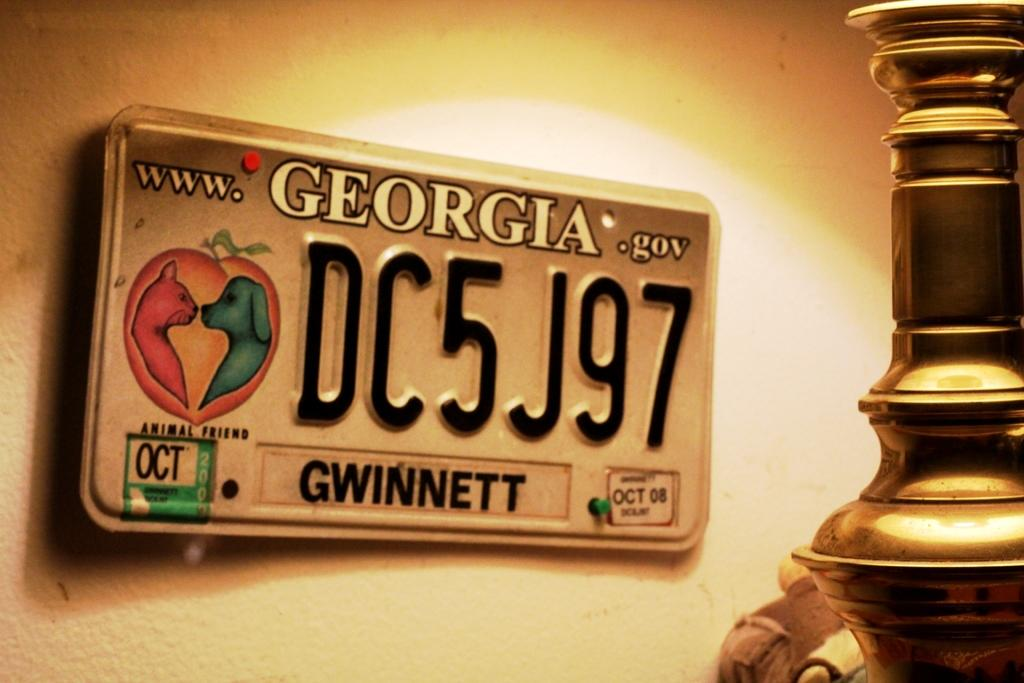What is the main object in the image? There is a board in the image. What is written or displayed on the board? There is text and numbers on the board. Can you describe the unspecified object on the right side of the image? Unfortunately, the facts provided do not give any details about the object on the right side of the image. What can be seen in the background of the image? There is a wall in the background of the image. What type of wool is being used for reading in the image? There is no wool or reading material present in the image. 